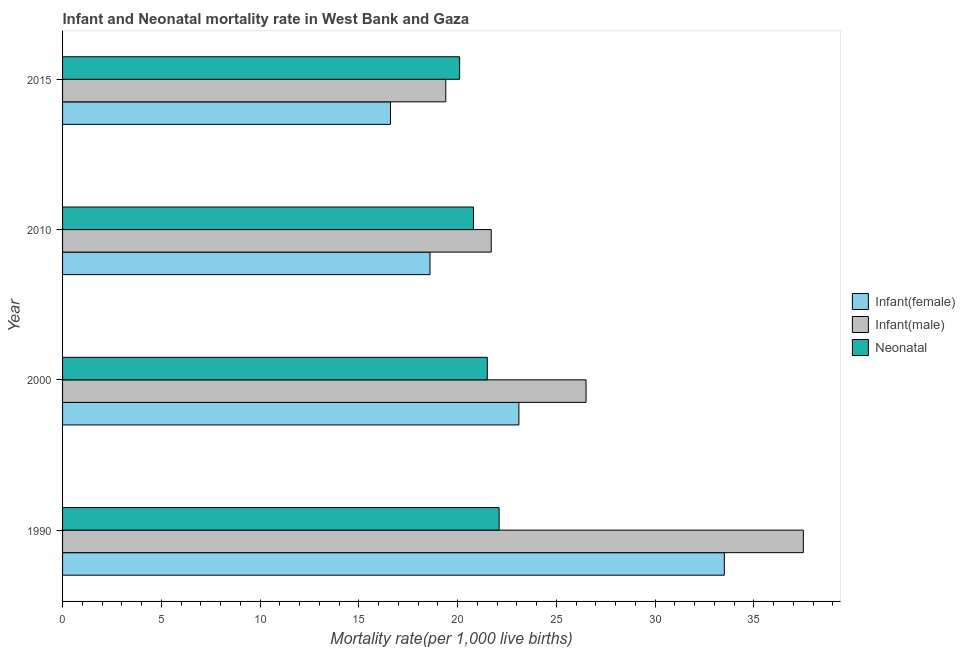How many different coloured bars are there?
Offer a very short reply. 3. How many groups of bars are there?
Keep it short and to the point. 4. Are the number of bars on each tick of the Y-axis equal?
Keep it short and to the point. Yes. What is the label of the 1st group of bars from the top?
Your answer should be compact. 2015. In how many cases, is the number of bars for a given year not equal to the number of legend labels?
Ensure brevity in your answer.  0. What is the infant mortality rate(male) in 2000?
Provide a succinct answer. 26.5. Across all years, what is the maximum infant mortality rate(male)?
Your answer should be very brief. 37.5. Across all years, what is the minimum infant mortality rate(female)?
Provide a succinct answer. 16.6. In which year was the infant mortality rate(female) maximum?
Offer a terse response. 1990. In which year was the infant mortality rate(female) minimum?
Your answer should be compact. 2015. What is the total infant mortality rate(male) in the graph?
Offer a very short reply. 105.1. What is the difference between the infant mortality rate(male) in 2000 and that in 2010?
Your response must be concise. 4.8. What is the difference between the neonatal mortality rate in 2000 and the infant mortality rate(male) in 2010?
Make the answer very short. -0.2. What is the average infant mortality rate(female) per year?
Provide a short and direct response. 22.95. What is the ratio of the neonatal mortality rate in 1990 to that in 2010?
Provide a succinct answer. 1.06. Is the infant mortality rate(male) in 1990 less than that in 2010?
Offer a terse response. No. What is the difference between the highest and the second highest infant mortality rate(female)?
Make the answer very short. 10.4. In how many years, is the infant mortality rate(female) greater than the average infant mortality rate(female) taken over all years?
Keep it short and to the point. 2. What does the 3rd bar from the top in 1990 represents?
Ensure brevity in your answer.  Infant(female). What does the 1st bar from the bottom in 1990 represents?
Offer a very short reply. Infant(female). What is the difference between two consecutive major ticks on the X-axis?
Provide a short and direct response. 5. Does the graph contain any zero values?
Offer a terse response. No. How are the legend labels stacked?
Ensure brevity in your answer.  Vertical. What is the title of the graph?
Offer a terse response. Infant and Neonatal mortality rate in West Bank and Gaza. What is the label or title of the X-axis?
Your answer should be compact. Mortality rate(per 1,0 live births). What is the Mortality rate(per 1,000 live births) of Infant(female) in 1990?
Your answer should be compact. 33.5. What is the Mortality rate(per 1,000 live births) of Infant(male) in 1990?
Keep it short and to the point. 37.5. What is the Mortality rate(per 1,000 live births) in Neonatal  in 1990?
Your answer should be compact. 22.1. What is the Mortality rate(per 1,000 live births) in Infant(female) in 2000?
Your answer should be compact. 23.1. What is the Mortality rate(per 1,000 live births) in Infant(male) in 2010?
Your response must be concise. 21.7. What is the Mortality rate(per 1,000 live births) of Neonatal  in 2010?
Offer a terse response. 20.8. What is the Mortality rate(per 1,000 live births) of Infant(female) in 2015?
Offer a terse response. 16.6. What is the Mortality rate(per 1,000 live births) in Infant(male) in 2015?
Keep it short and to the point. 19.4. What is the Mortality rate(per 1,000 live births) in Neonatal  in 2015?
Give a very brief answer. 20.1. Across all years, what is the maximum Mortality rate(per 1,000 live births) in Infant(female)?
Make the answer very short. 33.5. Across all years, what is the maximum Mortality rate(per 1,000 live births) of Infant(male)?
Provide a short and direct response. 37.5. Across all years, what is the maximum Mortality rate(per 1,000 live births) of Neonatal ?
Your answer should be compact. 22.1. Across all years, what is the minimum Mortality rate(per 1,000 live births) of Infant(male)?
Offer a terse response. 19.4. Across all years, what is the minimum Mortality rate(per 1,000 live births) in Neonatal ?
Provide a short and direct response. 20.1. What is the total Mortality rate(per 1,000 live births) in Infant(female) in the graph?
Your answer should be very brief. 91.8. What is the total Mortality rate(per 1,000 live births) of Infant(male) in the graph?
Provide a short and direct response. 105.1. What is the total Mortality rate(per 1,000 live births) of Neonatal  in the graph?
Offer a very short reply. 84.5. What is the difference between the Mortality rate(per 1,000 live births) of Infant(male) in 1990 and that in 2000?
Provide a succinct answer. 11. What is the difference between the Mortality rate(per 1,000 live births) of Neonatal  in 1990 and that in 2000?
Your answer should be very brief. 0.6. What is the difference between the Mortality rate(per 1,000 live births) of Neonatal  in 1990 and that in 2010?
Offer a terse response. 1.3. What is the difference between the Mortality rate(per 1,000 live births) of Infant(female) in 1990 and that in 2015?
Offer a very short reply. 16.9. What is the difference between the Mortality rate(per 1,000 live births) in Infant(male) in 1990 and that in 2015?
Make the answer very short. 18.1. What is the difference between the Mortality rate(per 1,000 live births) in Neonatal  in 1990 and that in 2015?
Ensure brevity in your answer.  2. What is the difference between the Mortality rate(per 1,000 live births) in Infant(female) in 2000 and that in 2010?
Keep it short and to the point. 4.5. What is the difference between the Mortality rate(per 1,000 live births) in Infant(male) in 2000 and that in 2010?
Provide a short and direct response. 4.8. What is the difference between the Mortality rate(per 1,000 live births) in Neonatal  in 2000 and that in 2010?
Your answer should be very brief. 0.7. What is the difference between the Mortality rate(per 1,000 live births) in Neonatal  in 2010 and that in 2015?
Your answer should be compact. 0.7. What is the difference between the Mortality rate(per 1,000 live births) of Infant(female) in 1990 and the Mortality rate(per 1,000 live births) of Infant(male) in 2000?
Your response must be concise. 7. What is the difference between the Mortality rate(per 1,000 live births) of Infant(female) in 1990 and the Mortality rate(per 1,000 live births) of Neonatal  in 2000?
Offer a very short reply. 12. What is the difference between the Mortality rate(per 1,000 live births) of Infant(female) in 1990 and the Mortality rate(per 1,000 live births) of Infant(male) in 2010?
Keep it short and to the point. 11.8. What is the difference between the Mortality rate(per 1,000 live births) in Infant(male) in 1990 and the Mortality rate(per 1,000 live births) in Neonatal  in 2010?
Give a very brief answer. 16.7. What is the difference between the Mortality rate(per 1,000 live births) of Infant(female) in 1990 and the Mortality rate(per 1,000 live births) of Infant(male) in 2015?
Offer a terse response. 14.1. What is the difference between the Mortality rate(per 1,000 live births) of Infant(female) in 1990 and the Mortality rate(per 1,000 live births) of Neonatal  in 2015?
Provide a short and direct response. 13.4. What is the difference between the Mortality rate(per 1,000 live births) in Infant(male) in 2000 and the Mortality rate(per 1,000 live births) in Neonatal  in 2010?
Your response must be concise. 5.7. What is the difference between the Mortality rate(per 1,000 live births) of Infant(female) in 2000 and the Mortality rate(per 1,000 live births) of Neonatal  in 2015?
Offer a very short reply. 3. What is the difference between the Mortality rate(per 1,000 live births) in Infant(male) in 2000 and the Mortality rate(per 1,000 live births) in Neonatal  in 2015?
Your response must be concise. 6.4. What is the average Mortality rate(per 1,000 live births) of Infant(female) per year?
Provide a short and direct response. 22.95. What is the average Mortality rate(per 1,000 live births) in Infant(male) per year?
Give a very brief answer. 26.27. What is the average Mortality rate(per 1,000 live births) in Neonatal  per year?
Provide a succinct answer. 21.12. In the year 1990, what is the difference between the Mortality rate(per 1,000 live births) of Infant(female) and Mortality rate(per 1,000 live births) of Infant(male)?
Make the answer very short. -4. In the year 1990, what is the difference between the Mortality rate(per 1,000 live births) of Infant(male) and Mortality rate(per 1,000 live births) of Neonatal ?
Your response must be concise. 15.4. In the year 2000, what is the difference between the Mortality rate(per 1,000 live births) of Infant(male) and Mortality rate(per 1,000 live births) of Neonatal ?
Offer a very short reply. 5. In the year 2010, what is the difference between the Mortality rate(per 1,000 live births) in Infant(female) and Mortality rate(per 1,000 live births) in Infant(male)?
Keep it short and to the point. -3.1. What is the ratio of the Mortality rate(per 1,000 live births) of Infant(female) in 1990 to that in 2000?
Offer a very short reply. 1.45. What is the ratio of the Mortality rate(per 1,000 live births) in Infant(male) in 1990 to that in 2000?
Ensure brevity in your answer.  1.42. What is the ratio of the Mortality rate(per 1,000 live births) of Neonatal  in 1990 to that in 2000?
Your answer should be very brief. 1.03. What is the ratio of the Mortality rate(per 1,000 live births) in Infant(female) in 1990 to that in 2010?
Give a very brief answer. 1.8. What is the ratio of the Mortality rate(per 1,000 live births) in Infant(male) in 1990 to that in 2010?
Provide a succinct answer. 1.73. What is the ratio of the Mortality rate(per 1,000 live births) in Infant(female) in 1990 to that in 2015?
Your answer should be compact. 2.02. What is the ratio of the Mortality rate(per 1,000 live births) of Infant(male) in 1990 to that in 2015?
Make the answer very short. 1.93. What is the ratio of the Mortality rate(per 1,000 live births) in Neonatal  in 1990 to that in 2015?
Provide a short and direct response. 1.1. What is the ratio of the Mortality rate(per 1,000 live births) in Infant(female) in 2000 to that in 2010?
Make the answer very short. 1.24. What is the ratio of the Mortality rate(per 1,000 live births) in Infant(male) in 2000 to that in 2010?
Your response must be concise. 1.22. What is the ratio of the Mortality rate(per 1,000 live births) of Neonatal  in 2000 to that in 2010?
Ensure brevity in your answer.  1.03. What is the ratio of the Mortality rate(per 1,000 live births) in Infant(female) in 2000 to that in 2015?
Make the answer very short. 1.39. What is the ratio of the Mortality rate(per 1,000 live births) of Infant(male) in 2000 to that in 2015?
Provide a short and direct response. 1.37. What is the ratio of the Mortality rate(per 1,000 live births) of Neonatal  in 2000 to that in 2015?
Provide a succinct answer. 1.07. What is the ratio of the Mortality rate(per 1,000 live births) of Infant(female) in 2010 to that in 2015?
Make the answer very short. 1.12. What is the ratio of the Mortality rate(per 1,000 live births) of Infant(male) in 2010 to that in 2015?
Provide a short and direct response. 1.12. What is the ratio of the Mortality rate(per 1,000 live births) of Neonatal  in 2010 to that in 2015?
Provide a short and direct response. 1.03. What is the difference between the highest and the lowest Mortality rate(per 1,000 live births) of Infant(male)?
Ensure brevity in your answer.  18.1. What is the difference between the highest and the lowest Mortality rate(per 1,000 live births) in Neonatal ?
Ensure brevity in your answer.  2. 